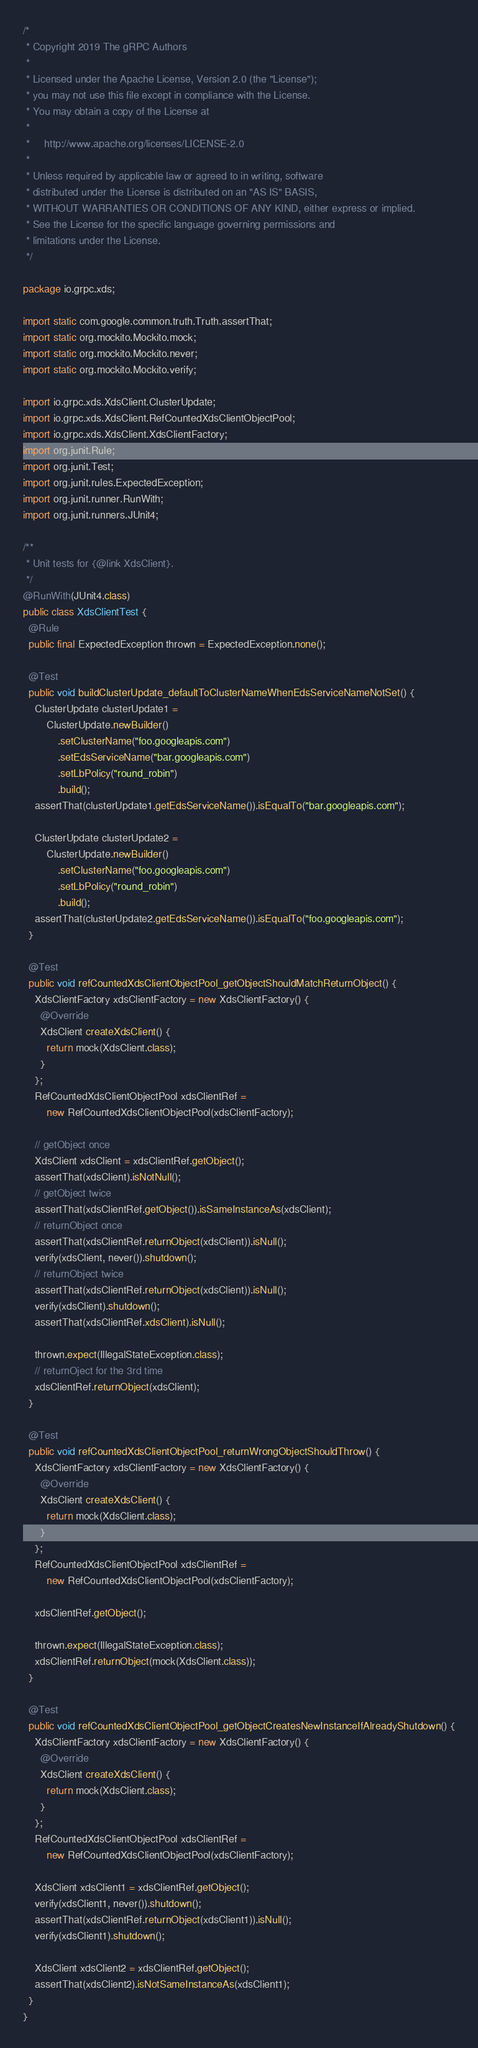Convert code to text. <code><loc_0><loc_0><loc_500><loc_500><_Java_>/*
 * Copyright 2019 The gRPC Authors
 *
 * Licensed under the Apache License, Version 2.0 (the "License");
 * you may not use this file except in compliance with the License.
 * You may obtain a copy of the License at
 *
 *     http://www.apache.org/licenses/LICENSE-2.0
 *
 * Unless required by applicable law or agreed to in writing, software
 * distributed under the License is distributed on an "AS IS" BASIS,
 * WITHOUT WARRANTIES OR CONDITIONS OF ANY KIND, either express or implied.
 * See the License for the specific language governing permissions and
 * limitations under the License.
 */

package io.grpc.xds;

import static com.google.common.truth.Truth.assertThat;
import static org.mockito.Mockito.mock;
import static org.mockito.Mockito.never;
import static org.mockito.Mockito.verify;

import io.grpc.xds.XdsClient.ClusterUpdate;
import io.grpc.xds.XdsClient.RefCountedXdsClientObjectPool;
import io.grpc.xds.XdsClient.XdsClientFactory;
import org.junit.Rule;
import org.junit.Test;
import org.junit.rules.ExpectedException;
import org.junit.runner.RunWith;
import org.junit.runners.JUnit4;

/**
 * Unit tests for {@link XdsClient}.
 */
@RunWith(JUnit4.class)
public class XdsClientTest {
  @Rule
  public final ExpectedException thrown = ExpectedException.none();

  @Test
  public void buildClusterUpdate_defaultToClusterNameWhenEdsServiceNameNotSet() {
    ClusterUpdate clusterUpdate1 =
        ClusterUpdate.newBuilder()
            .setClusterName("foo.googleapis.com")
            .setEdsServiceName("bar.googleapis.com")
            .setLbPolicy("round_robin")
            .build();
    assertThat(clusterUpdate1.getEdsServiceName()).isEqualTo("bar.googleapis.com");

    ClusterUpdate clusterUpdate2 =
        ClusterUpdate.newBuilder()
            .setClusterName("foo.googleapis.com")
            .setLbPolicy("round_robin")
            .build();
    assertThat(clusterUpdate2.getEdsServiceName()).isEqualTo("foo.googleapis.com");
  }

  @Test
  public void refCountedXdsClientObjectPool_getObjectShouldMatchReturnObject() {
    XdsClientFactory xdsClientFactory = new XdsClientFactory() {
      @Override
      XdsClient createXdsClient() {
        return mock(XdsClient.class);
      }
    };
    RefCountedXdsClientObjectPool xdsClientRef =
        new RefCountedXdsClientObjectPool(xdsClientFactory);

    // getObject once
    XdsClient xdsClient = xdsClientRef.getObject();
    assertThat(xdsClient).isNotNull();
    // getObject twice
    assertThat(xdsClientRef.getObject()).isSameInstanceAs(xdsClient);
    // returnObject once
    assertThat(xdsClientRef.returnObject(xdsClient)).isNull();
    verify(xdsClient, never()).shutdown();
    // returnObject twice
    assertThat(xdsClientRef.returnObject(xdsClient)).isNull();
    verify(xdsClient).shutdown();
    assertThat(xdsClientRef.xdsClient).isNull();

    thrown.expect(IllegalStateException.class);
    // returnOject for the 3rd time
    xdsClientRef.returnObject(xdsClient);
  }

  @Test
  public void refCountedXdsClientObjectPool_returnWrongObjectShouldThrow() {
    XdsClientFactory xdsClientFactory = new XdsClientFactory() {
      @Override
      XdsClient createXdsClient() {
        return mock(XdsClient.class);
      }
    };
    RefCountedXdsClientObjectPool xdsClientRef =
        new RefCountedXdsClientObjectPool(xdsClientFactory);

    xdsClientRef.getObject();

    thrown.expect(IllegalStateException.class);
    xdsClientRef.returnObject(mock(XdsClient.class));
  }

  @Test
  public void refCountedXdsClientObjectPool_getObjectCreatesNewInstanceIfAlreadyShutdown() {
    XdsClientFactory xdsClientFactory = new XdsClientFactory() {
      @Override
      XdsClient createXdsClient() {
        return mock(XdsClient.class);
      }
    };
    RefCountedXdsClientObjectPool xdsClientRef =
        new RefCountedXdsClientObjectPool(xdsClientFactory);

    XdsClient xdsClient1 = xdsClientRef.getObject();
    verify(xdsClient1, never()).shutdown();
    assertThat(xdsClientRef.returnObject(xdsClient1)).isNull();
    verify(xdsClient1).shutdown();

    XdsClient xdsClient2 = xdsClientRef.getObject();
    assertThat(xdsClient2).isNotSameInstanceAs(xdsClient1);
  }
}
</code> 